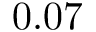<formula> <loc_0><loc_0><loc_500><loc_500>0 . 0 7</formula> 